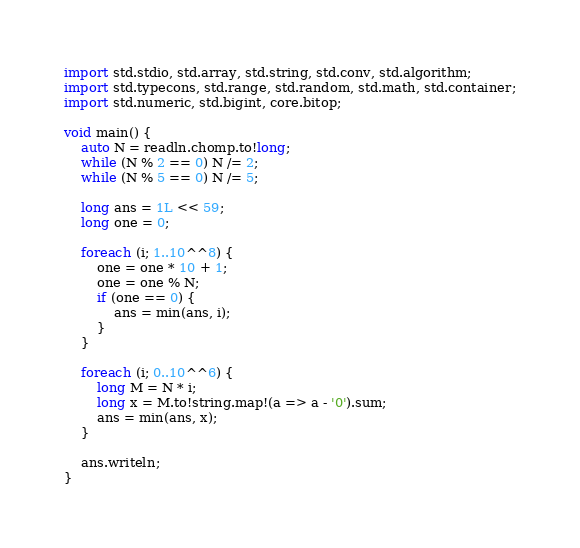<code> <loc_0><loc_0><loc_500><loc_500><_D_>import std.stdio, std.array, std.string, std.conv, std.algorithm;
import std.typecons, std.range, std.random, std.math, std.container;
import std.numeric, std.bigint, core.bitop;

void main() {
    auto N = readln.chomp.to!long;
    while (N % 2 == 0) N /= 2;
    while (N % 5 == 0) N /= 5;

    long ans = 1L << 59;
    long one = 0;

    foreach (i; 1..10^^8) {
        one = one * 10 + 1;
        one = one % N;
        if (one == 0) {
            ans = min(ans, i);
        }
    }

    foreach (i; 0..10^^6) {
        long M = N * i;
        long x = M.to!string.map!(a => a - '0').sum;
        ans = min(ans, x);
    }

    ans.writeln;
}
</code> 